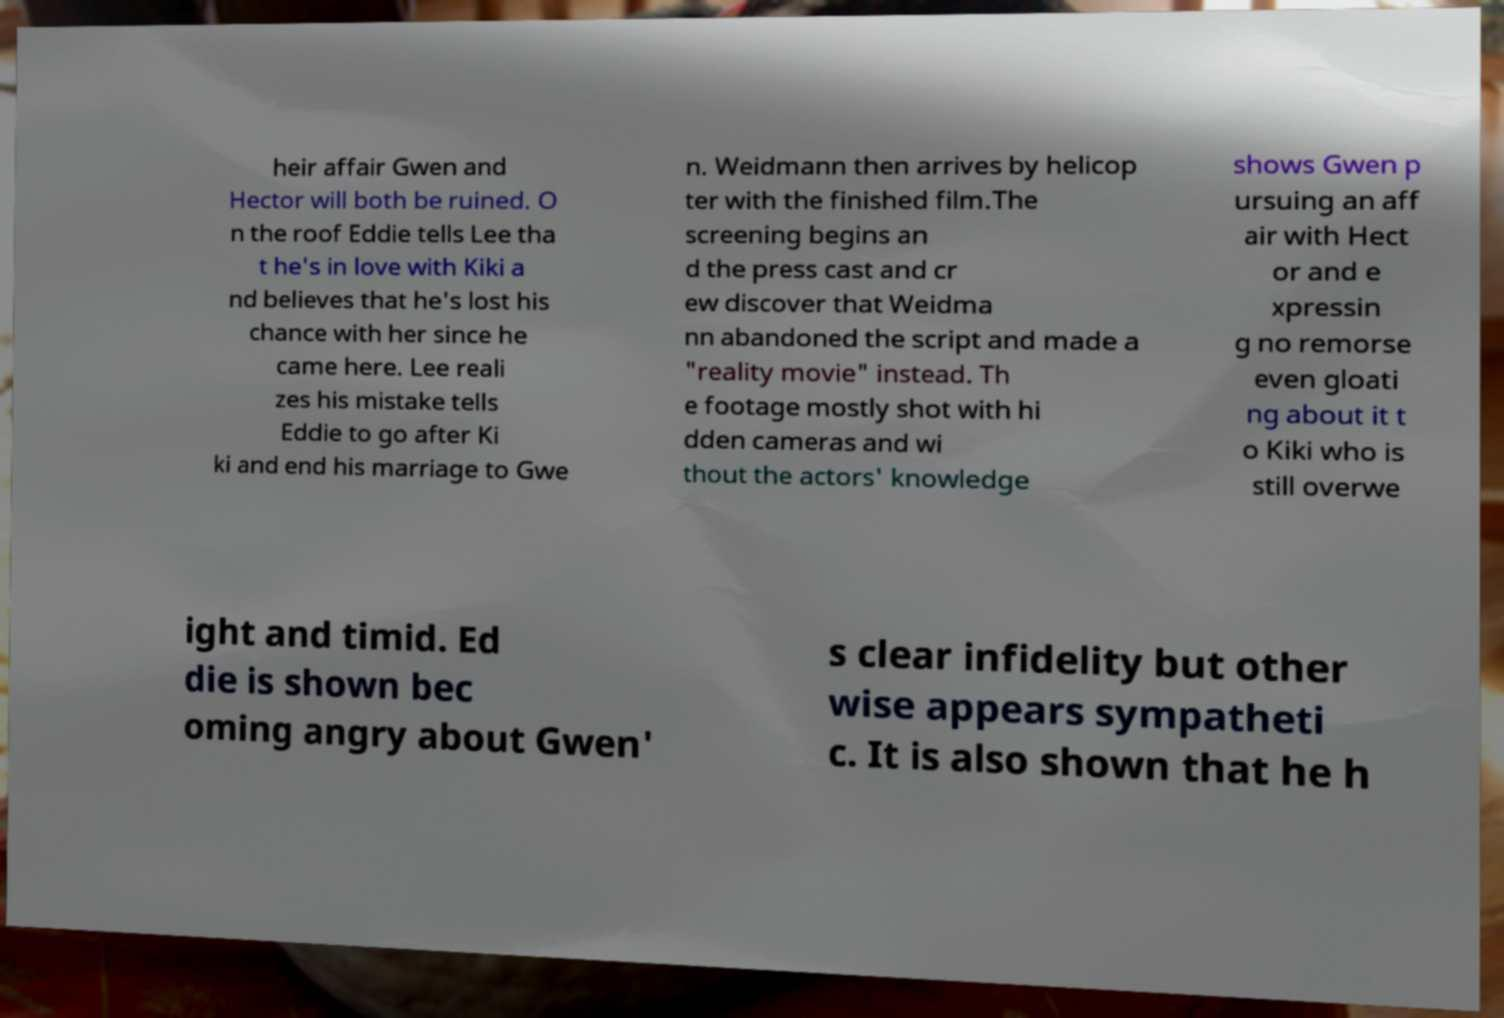Please read and relay the text visible in this image. What does it say? heir affair Gwen and Hector will both be ruined. O n the roof Eddie tells Lee tha t he's in love with Kiki a nd believes that he's lost his chance with her since he came here. Lee reali zes his mistake tells Eddie to go after Ki ki and end his marriage to Gwe n. Weidmann then arrives by helicop ter with the finished film.The screening begins an d the press cast and cr ew discover that Weidma nn abandoned the script and made a "reality movie" instead. Th e footage mostly shot with hi dden cameras and wi thout the actors' knowledge shows Gwen p ursuing an aff air with Hect or and e xpressin g no remorse even gloati ng about it t o Kiki who is still overwe ight and timid. Ed die is shown bec oming angry about Gwen' s clear infidelity but other wise appears sympatheti c. It is also shown that he h 